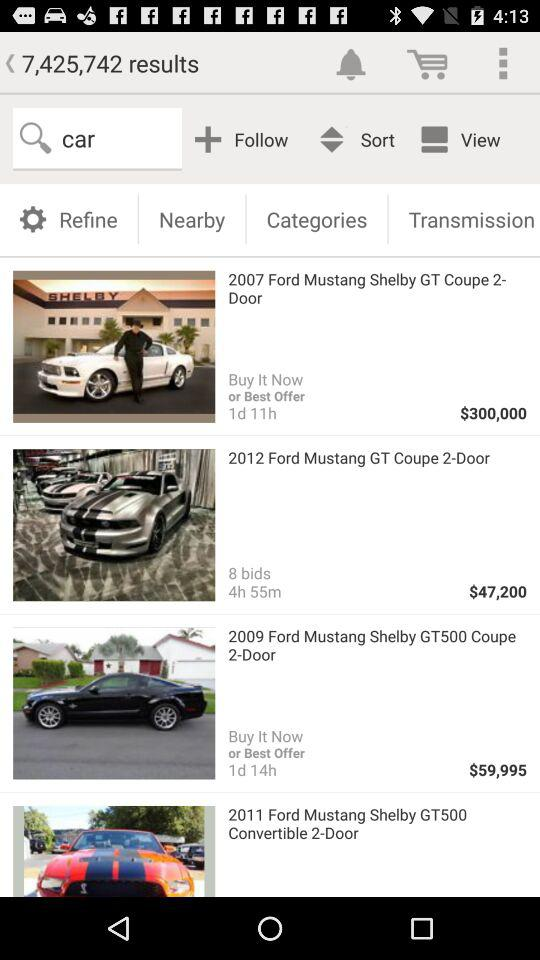How many bids are there for "2012 Ford Mustang GT Coupe 2-Door"? There are 8 bids for "2012 Ford Mustang GT Coupe 2-Door". 